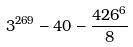<formula> <loc_0><loc_0><loc_500><loc_500>3 ^ { 2 6 9 } - 4 0 - \frac { 4 2 6 ^ { 6 } } { 8 }</formula> 